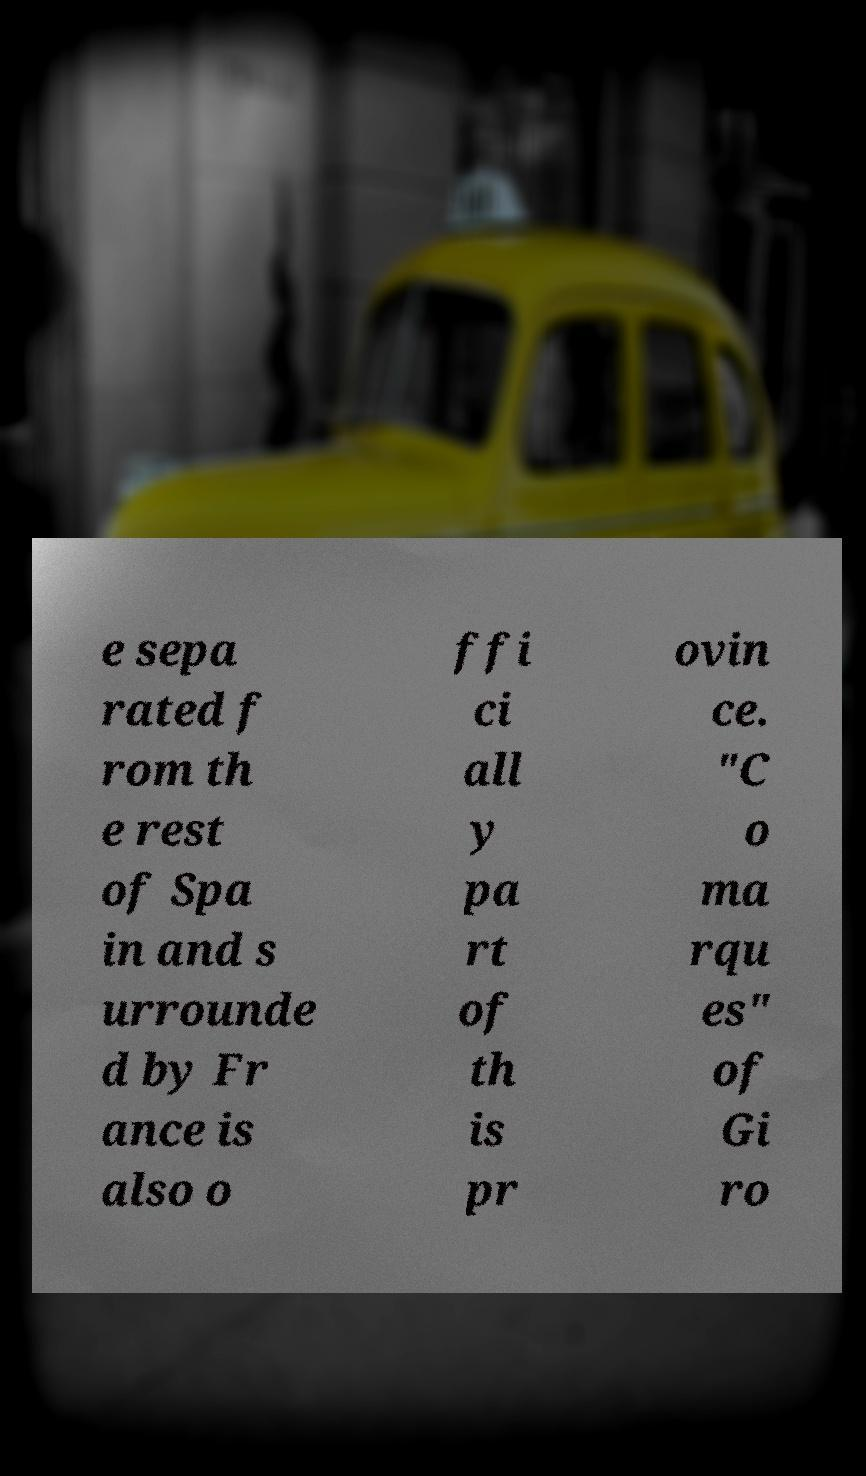Could you extract and type out the text from this image? e sepa rated f rom th e rest of Spa in and s urrounde d by Fr ance is also o ffi ci all y pa rt of th is pr ovin ce. "C o ma rqu es" of Gi ro 